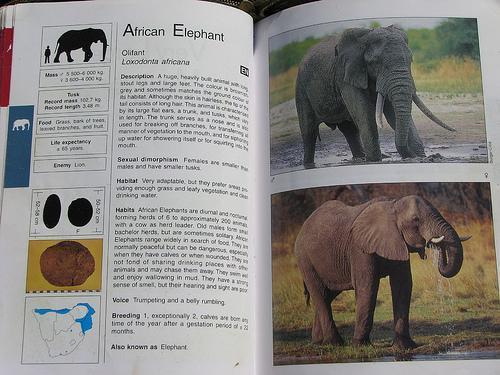How many elephants are on the right page?
Give a very brief answer. 2. 